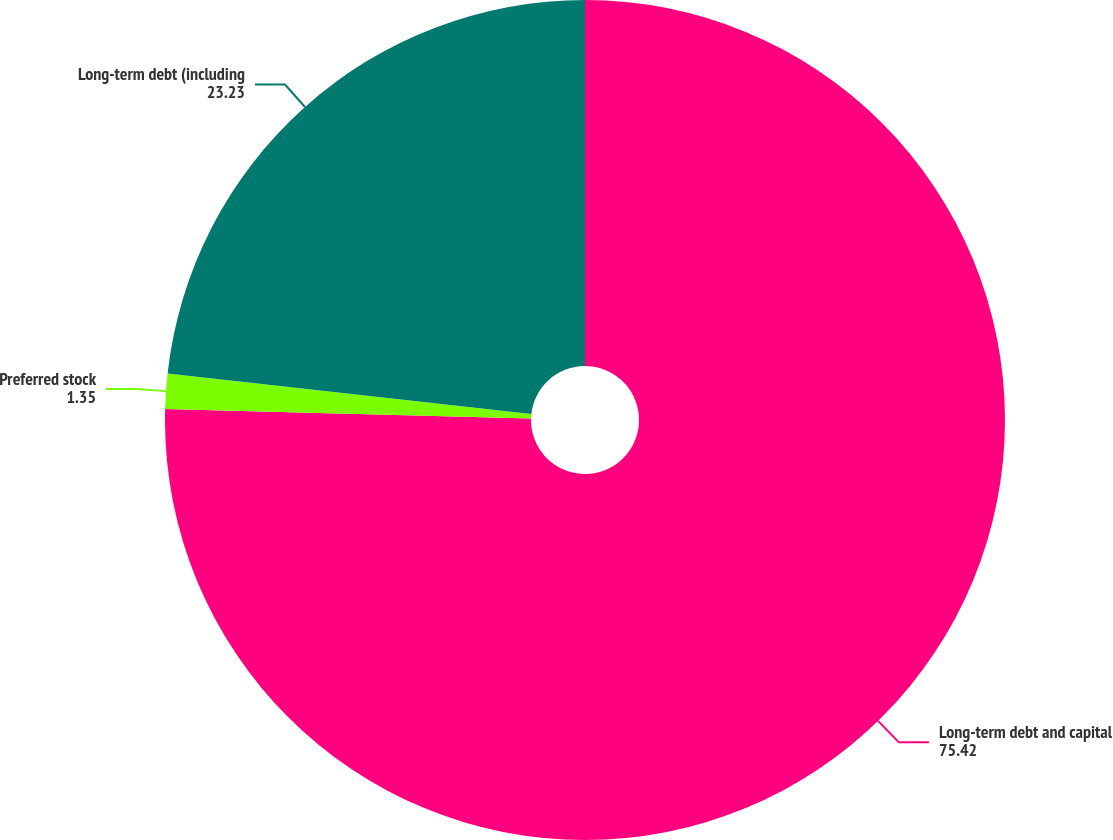Convert chart. <chart><loc_0><loc_0><loc_500><loc_500><pie_chart><fcel>Long-term debt and capital<fcel>Preferred stock<fcel>Long-term debt (including<nl><fcel>75.42%<fcel>1.35%<fcel>23.23%<nl></chart> 